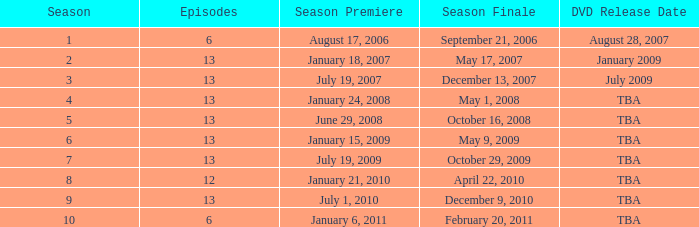On what date was the DVD released for the season with fewer than 13 episodes that aired before season 8? August 28, 2007. 